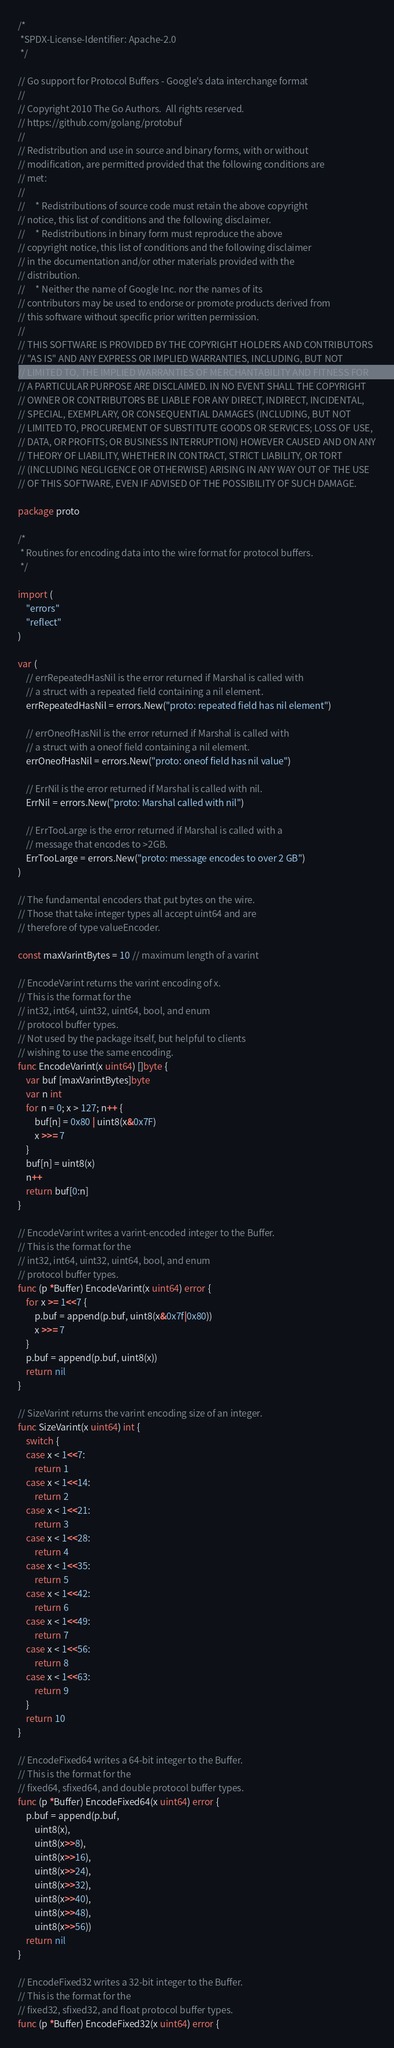Convert code to text. <code><loc_0><loc_0><loc_500><loc_500><_Go_>/*
 *SPDX-License-Identifier: Apache-2.0
 */

// Go support for Protocol Buffers - Google's data interchange format
//
// Copyright 2010 The Go Authors.  All rights reserved.
// https://github.com/golang/protobuf
//
// Redistribution and use in source and binary forms, with or without
// modification, are permitted provided that the following conditions are
// met:
//
//     * Redistributions of source code must retain the above copyright
// notice, this list of conditions and the following disclaimer.
//     * Redistributions in binary form must reproduce the above
// copyright notice, this list of conditions and the following disclaimer
// in the documentation and/or other materials provided with the
// distribution.
//     * Neither the name of Google Inc. nor the names of its
// contributors may be used to endorse or promote products derived from
// this software without specific prior written permission.
//
// THIS SOFTWARE IS PROVIDED BY THE COPYRIGHT HOLDERS AND CONTRIBUTORS
// "AS IS" AND ANY EXPRESS OR IMPLIED WARRANTIES, INCLUDING, BUT NOT
// LIMITED TO, THE IMPLIED WARRANTIES OF MERCHANTABILITY AND FITNESS FOR
// A PARTICULAR PURPOSE ARE DISCLAIMED. IN NO EVENT SHALL THE COPYRIGHT
// OWNER OR CONTRIBUTORS BE LIABLE FOR ANY DIRECT, INDIRECT, INCIDENTAL,
// SPECIAL, EXEMPLARY, OR CONSEQUENTIAL DAMAGES (INCLUDING, BUT NOT
// LIMITED TO, PROCUREMENT OF SUBSTITUTE GOODS OR SERVICES; LOSS OF USE,
// DATA, OR PROFITS; OR BUSINESS INTERRUPTION) HOWEVER CAUSED AND ON ANY
// THEORY OF LIABILITY, WHETHER IN CONTRACT, STRICT LIABILITY, OR TORT
// (INCLUDING NEGLIGENCE OR OTHERWISE) ARISING IN ANY WAY OUT OF THE USE
// OF THIS SOFTWARE, EVEN IF ADVISED OF THE POSSIBILITY OF SUCH DAMAGE.

package proto

/*
 * Routines for encoding data into the wire format for protocol buffers.
 */

import (
	"errors"
	"reflect"
)

var (
	// errRepeatedHasNil is the error returned if Marshal is called with
	// a struct with a repeated field containing a nil element.
	errRepeatedHasNil = errors.New("proto: repeated field has nil element")

	// errOneofHasNil is the error returned if Marshal is called with
	// a struct with a oneof field containing a nil element.
	errOneofHasNil = errors.New("proto: oneof field has nil value")

	// ErrNil is the error returned if Marshal is called with nil.
	ErrNil = errors.New("proto: Marshal called with nil")

	// ErrTooLarge is the error returned if Marshal is called with a
	// message that encodes to >2GB.
	ErrTooLarge = errors.New("proto: message encodes to over 2 GB")
)

// The fundamental encoders that put bytes on the wire.
// Those that take integer types all accept uint64 and are
// therefore of type valueEncoder.

const maxVarintBytes = 10 // maximum length of a varint

// EncodeVarint returns the varint encoding of x.
// This is the format for the
// int32, int64, uint32, uint64, bool, and enum
// protocol buffer types.
// Not used by the package itself, but helpful to clients
// wishing to use the same encoding.
func EncodeVarint(x uint64) []byte {
	var buf [maxVarintBytes]byte
	var n int
	for n = 0; x > 127; n++ {
		buf[n] = 0x80 | uint8(x&0x7F)
		x >>= 7
	}
	buf[n] = uint8(x)
	n++
	return buf[0:n]
}

// EncodeVarint writes a varint-encoded integer to the Buffer.
// This is the format for the
// int32, int64, uint32, uint64, bool, and enum
// protocol buffer types.
func (p *Buffer) EncodeVarint(x uint64) error {
	for x >= 1<<7 {
		p.buf = append(p.buf, uint8(x&0x7f|0x80))
		x >>= 7
	}
	p.buf = append(p.buf, uint8(x))
	return nil
}

// SizeVarint returns the varint encoding size of an integer.
func SizeVarint(x uint64) int {
	switch {
	case x < 1<<7:
		return 1
	case x < 1<<14:
		return 2
	case x < 1<<21:
		return 3
	case x < 1<<28:
		return 4
	case x < 1<<35:
		return 5
	case x < 1<<42:
		return 6
	case x < 1<<49:
		return 7
	case x < 1<<56:
		return 8
	case x < 1<<63:
		return 9
	}
	return 10
}

// EncodeFixed64 writes a 64-bit integer to the Buffer.
// This is the format for the
// fixed64, sfixed64, and double protocol buffer types.
func (p *Buffer) EncodeFixed64(x uint64) error {
	p.buf = append(p.buf,
		uint8(x),
		uint8(x>>8),
		uint8(x>>16),
		uint8(x>>24),
		uint8(x>>32),
		uint8(x>>40),
		uint8(x>>48),
		uint8(x>>56))
	return nil
}

// EncodeFixed32 writes a 32-bit integer to the Buffer.
// This is the format for the
// fixed32, sfixed32, and float protocol buffer types.
func (p *Buffer) EncodeFixed32(x uint64) error {</code> 